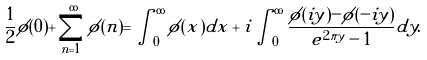Convert formula to latex. <formula><loc_0><loc_0><loc_500><loc_500>\frac { 1 } { 2 } \phi ( 0 ) + \sum _ { n = 1 } ^ { \infty } \phi ( n ) = \int _ { 0 } ^ { \infty } \phi ( x ) d x + i \int _ { 0 } ^ { \infty } \frac { \phi ( i y ) - \phi ( - i y ) } { e ^ { 2 \pi y } - 1 } d y .</formula> 